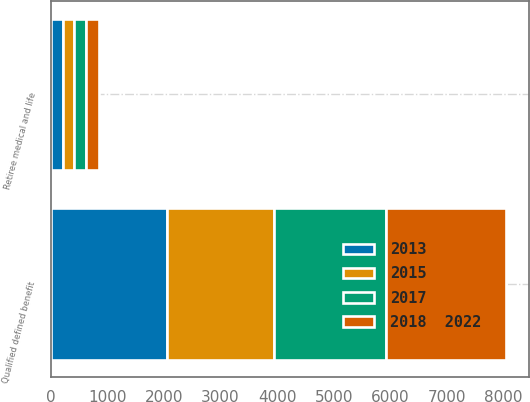Convert chart. <chart><loc_0><loc_0><loc_500><loc_500><stacked_bar_chart><ecel><fcel>Qualified defined benefit<fcel>Retiree medical and life<nl><fcel>2015<fcel>1900<fcel>200<nl><fcel>2017<fcel>1970<fcel>210<nl><fcel>2013<fcel>2050<fcel>220<nl><fcel>2018  2022<fcel>2130<fcel>220<nl></chart> 